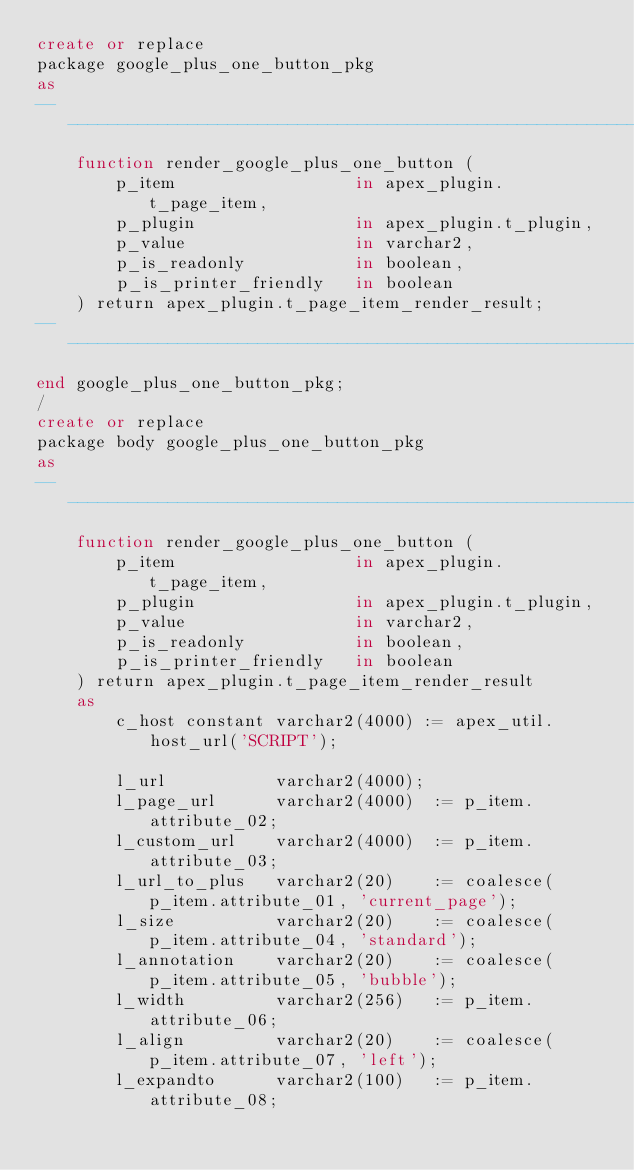<code> <loc_0><loc_0><loc_500><loc_500><_SQL_>create or replace
package google_plus_one_button_pkg
as
-------------------------------------------------------------------------------
	function render_google_plus_one_button (
		p_item					in apex_plugin.t_page_item,
		p_plugin				in apex_plugin.t_plugin,
		p_value					in varchar2,
		p_is_readonly			in boolean,
		p_is_printer_friendly	in boolean
	) return apex_plugin.t_page_item_render_result;
-------------------------------------------------------------------------------
end google_plus_one_button_pkg;
/
create or replace
package body google_plus_one_button_pkg
as
--------------------------------------------------------------------------------
	function render_google_plus_one_button (
		p_item					in apex_plugin.t_page_item,
		p_plugin				in apex_plugin.t_plugin,
		p_value					in varchar2,
		p_is_readonly			in boolean,
		p_is_printer_friendly	in boolean
	) return apex_plugin.t_page_item_render_result
	as
		c_host constant varchar2(4000) := apex_util.host_url('SCRIPT');

		l_url			varchar2(4000);
		l_page_url		varchar2(4000)	:= p_item.attribute_02;
		l_custom_url	varchar2(4000)	:= p_item.attribute_03;
		l_url_to_plus	varchar2(20)	:= coalesce(p_item.attribute_01, 'current_page');
		l_size			varchar2(20)	:= coalesce(p_item.attribute_04, 'standard');
		l_annotation	varchar2(20)	:= coalesce(p_item.attribute_05, 'bubble');
		l_width			varchar2(256)	:= p_item.attribute_06;
		l_align			varchar2(20)	:= coalesce(p_item.attribute_07, 'left');
		l_expandto		varchar2(100)	:= p_item.attribute_08;</code> 